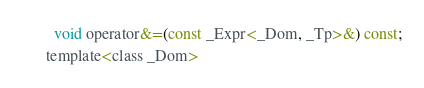<code> <loc_0><loc_0><loc_500><loc_500><_C_>        void operator&=(const _Expr<_Dom, _Tp>&) const;
      template<class _Dom></code> 